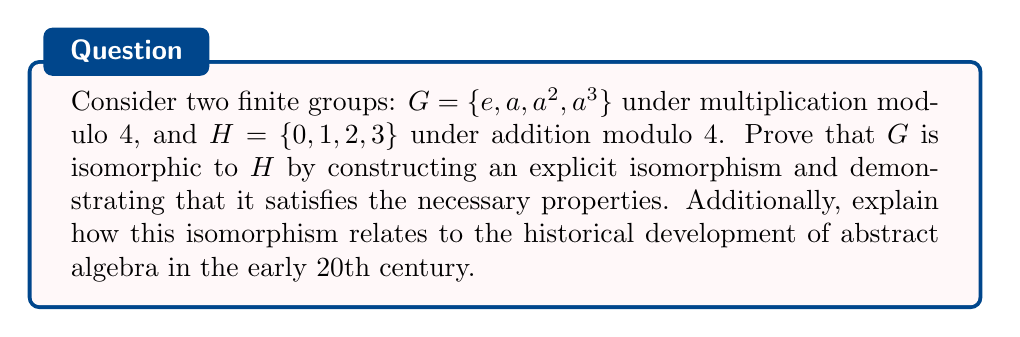Teach me how to tackle this problem. To prove that the groups $G$ and $H$ are isomorphic, we need to construct a bijective homomorphism between them. Let's approach this step-by-step:

1) First, let's define a mapping $\phi: G \to H$ as follows:
   $$\phi(e) = 0$$
   $$\phi(a) = 1$$
   $$\phi(a^2) = 2$$
   $$\phi(a^3) = 3$$

2) To prove that $\phi$ is an isomorphism, we need to show that it is:
   a) Bijective (one-to-one and onto)
   b) A homomorphism (preserves the group operation)

3) Bijectivity:
   - $\phi$ is injective (one-to-one) because each element in $G$ maps to a distinct element in $H$.
   - $\phi$ is surjective (onto) because every element in $H$ is mapped to by an element in $G$.
   Therefore, $\phi$ is bijective.

4) Homomorphism property:
   We need to show that for all $x, y \in G$, $\phi(xy) = \phi(x) + \phi(y)$ (mod 4).
   Let's verify this for all possible combinations:
   
   $$\phi(e \cdot e) = \phi(e) = 0 = 0 + 0 = \phi(e) + \phi(e)$$
   $$\phi(e \cdot a) = \phi(a) = 1 = 0 + 1 = \phi(e) + \phi(a)$$
   $$\phi(a \cdot a) = \phi(a^2) = 2 = 1 + 1 = \phi(a) + \phi(a)$$
   $$\phi(a \cdot a^2) = \phi(a^3) = 3 = 1 + 2 = \phi(a) + \phi(a^2)$$
   $$\phi(a \cdot a^3) = \phi(e) = 0 = 1 + 3 = \phi(a) + \phi(a^3)$$
   
   (and so on for all other combinations)

5) Since $\phi$ is both bijective and a homomorphism, it is an isomorphism. Therefore, $G$ is isomorphic to $H$.

Historical context:
The concept of group isomorphisms played a crucial role in the development of abstract algebra in the early 20th century. Mathematicians like Emmy Noether and Emil Artin recognized that studying the abstract structure of groups, rather than specific representations, could lead to powerful generalizations. This isomorphism between a multiplicative and an additive group exemplifies how seemingly different mathematical structures can have the same underlying abstract structure, a key insight that drove the field forward.
Answer: The groups $G$ and $H$ are isomorphic. An explicit isomorphism $\phi: G \to H$ is given by:

$$\phi(e) = 0, \phi(a) = 1, \phi(a^2) = 2, \phi(a^3) = 3$$

This mapping is bijective and preserves the group operation, satisfying $\phi(xy) = \phi(x) + \phi(y)$ (mod 4) for all $x, y \in G$. Therefore, $\phi$ is an isomorphism between $G$ and $H$. 